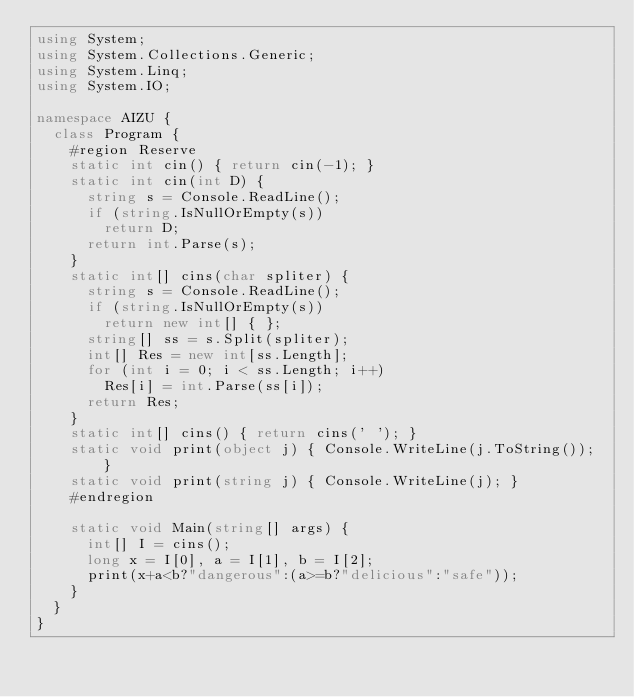<code> <loc_0><loc_0><loc_500><loc_500><_C#_>using System;
using System.Collections.Generic;
using System.Linq;
using System.IO;

namespace AIZU {
	class Program {
		#region Reserve
		static int cin() { return cin(-1); }
		static int cin(int D) {
			string s = Console.ReadLine();
			if (string.IsNullOrEmpty(s))
				return D;
			return int.Parse(s);
		}
		static int[] cins(char spliter) {
			string s = Console.ReadLine();
			if (string.IsNullOrEmpty(s))
				return new int[] { };
			string[] ss = s.Split(spliter);
			int[] Res = new int[ss.Length];
			for (int i = 0; i < ss.Length; i++)
				Res[i] = int.Parse(ss[i]);
			return Res;
		}
		static int[] cins() { return cins(' '); }
		static void print(object j) { Console.WriteLine(j.ToString()); }
		static void print(string j) { Console.WriteLine(j); }
		#endregion
		
		static void Main(string[] args) {
			int[] I = cins();
			long x = I[0], a = I[1], b = I[2];
			print(x+a<b?"dangerous":(a>=b?"delicious":"safe"));
		}
	}
}</code> 